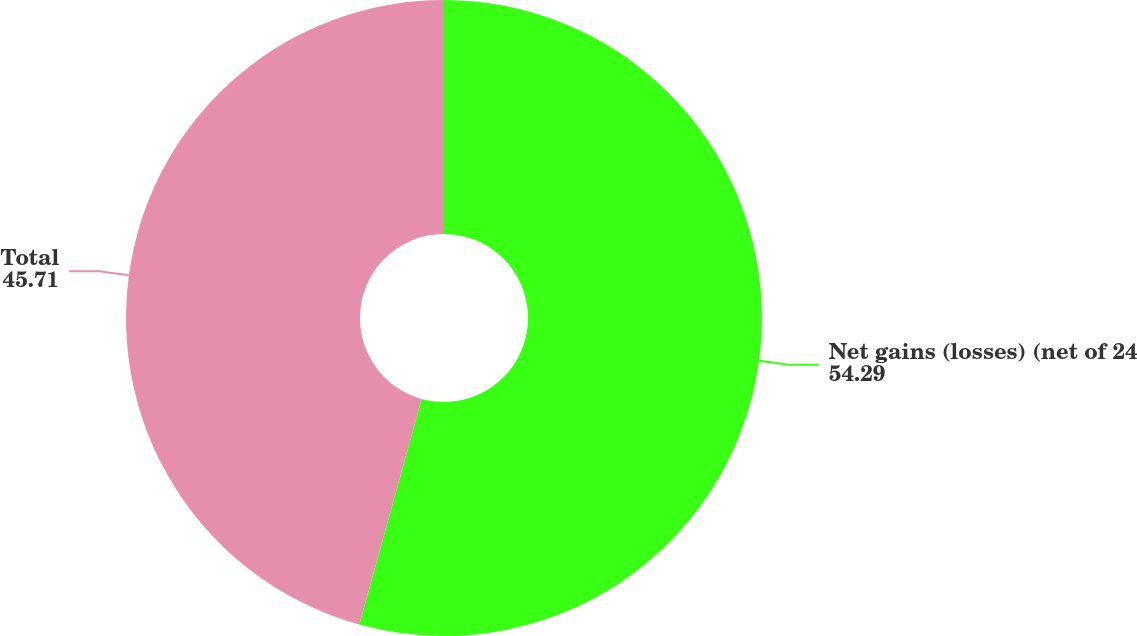Convert chart. <chart><loc_0><loc_0><loc_500><loc_500><pie_chart><fcel>Net gains (losses) (net of 24<fcel>Total<nl><fcel>54.29%<fcel>45.71%<nl></chart> 